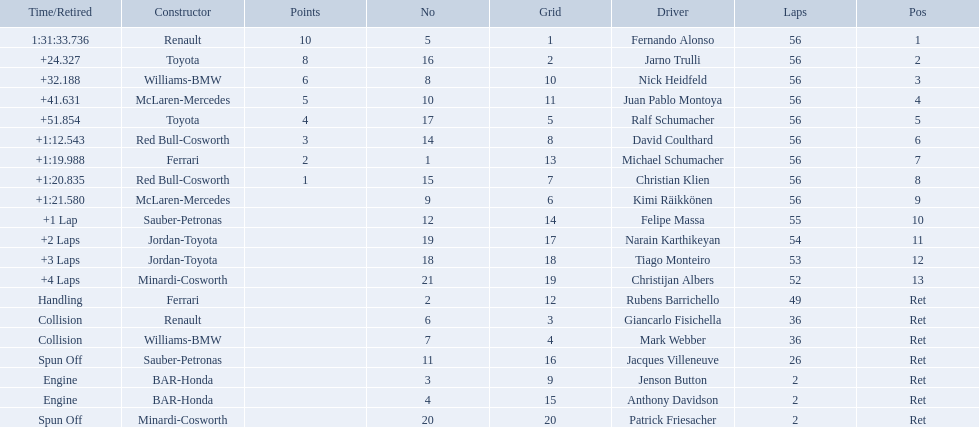Who was fernando alonso's instructor? Renault. How many laps did fernando alonso run? 56. How long did it take alonso to complete the race? 1:31:33.736. 